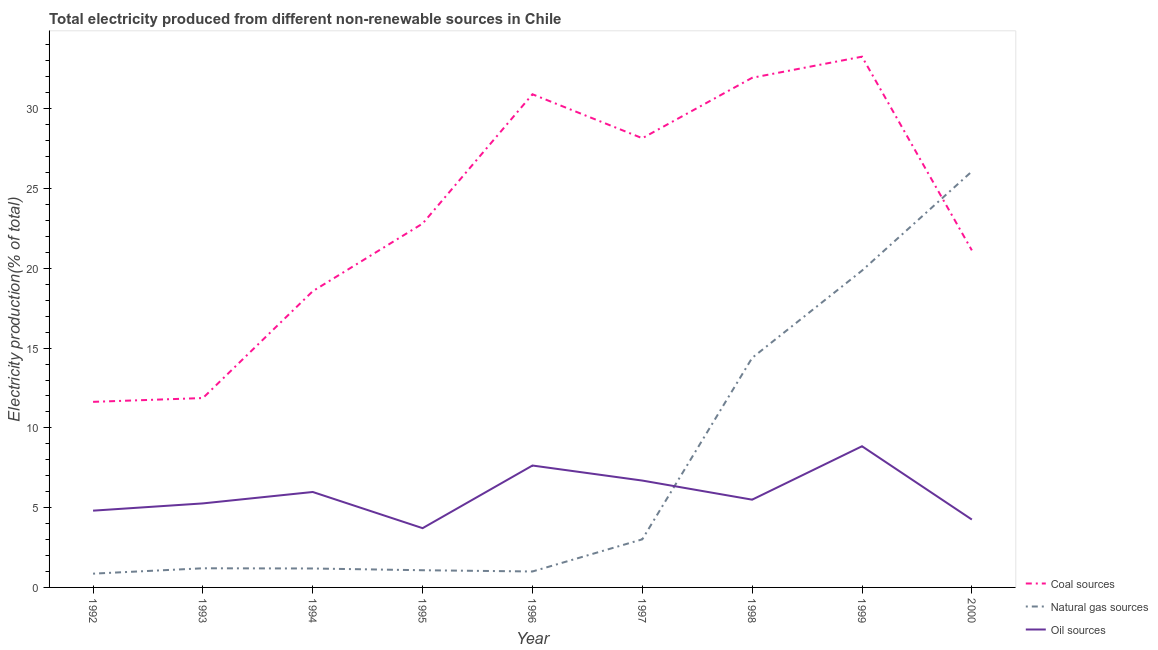Is the number of lines equal to the number of legend labels?
Give a very brief answer. Yes. What is the percentage of electricity produced by natural gas in 1992?
Your answer should be compact. 0.86. Across all years, what is the maximum percentage of electricity produced by coal?
Provide a succinct answer. 33.26. Across all years, what is the minimum percentage of electricity produced by coal?
Ensure brevity in your answer.  11.63. In which year was the percentage of electricity produced by coal minimum?
Ensure brevity in your answer.  1992. What is the total percentage of electricity produced by natural gas in the graph?
Ensure brevity in your answer.  68.66. What is the difference between the percentage of electricity produced by coal in 1993 and that in 1995?
Provide a short and direct response. -10.93. What is the difference between the percentage of electricity produced by oil sources in 1994 and the percentage of electricity produced by coal in 1992?
Your answer should be very brief. -5.65. What is the average percentage of electricity produced by coal per year?
Make the answer very short. 23.36. In the year 1996, what is the difference between the percentage of electricity produced by natural gas and percentage of electricity produced by coal?
Ensure brevity in your answer.  -29.91. What is the ratio of the percentage of electricity produced by coal in 1993 to that in 1995?
Your response must be concise. 0.52. Is the percentage of electricity produced by oil sources in 1994 less than that in 1999?
Offer a very short reply. Yes. What is the difference between the highest and the second highest percentage of electricity produced by coal?
Keep it short and to the point. 1.32. What is the difference between the highest and the lowest percentage of electricity produced by oil sources?
Offer a terse response. 5.13. In how many years, is the percentage of electricity produced by natural gas greater than the average percentage of electricity produced by natural gas taken over all years?
Provide a short and direct response. 3. Is the sum of the percentage of electricity produced by coal in 1992 and 2000 greater than the maximum percentage of electricity produced by oil sources across all years?
Your response must be concise. Yes. How many years are there in the graph?
Make the answer very short. 9. What is the difference between two consecutive major ticks on the Y-axis?
Provide a succinct answer. 5. Are the values on the major ticks of Y-axis written in scientific E-notation?
Ensure brevity in your answer.  No. Does the graph contain any zero values?
Your answer should be compact. No. Does the graph contain grids?
Ensure brevity in your answer.  No. How many legend labels are there?
Your answer should be compact. 3. What is the title of the graph?
Make the answer very short. Total electricity produced from different non-renewable sources in Chile. What is the label or title of the X-axis?
Ensure brevity in your answer.  Year. What is the Electricity production(% of total) in Coal sources in 1992?
Ensure brevity in your answer.  11.63. What is the Electricity production(% of total) in Natural gas sources in 1992?
Provide a succinct answer. 0.86. What is the Electricity production(% of total) in Oil sources in 1992?
Your response must be concise. 4.81. What is the Electricity production(% of total) of Coal sources in 1993?
Give a very brief answer. 11.87. What is the Electricity production(% of total) of Natural gas sources in 1993?
Provide a short and direct response. 1.2. What is the Electricity production(% of total) in Oil sources in 1993?
Provide a short and direct response. 5.27. What is the Electricity production(% of total) in Coal sources in 1994?
Provide a succinct answer. 18.57. What is the Electricity production(% of total) in Natural gas sources in 1994?
Ensure brevity in your answer.  1.19. What is the Electricity production(% of total) of Oil sources in 1994?
Provide a short and direct response. 5.98. What is the Electricity production(% of total) of Coal sources in 1995?
Your answer should be very brief. 22.8. What is the Electricity production(% of total) of Natural gas sources in 1995?
Ensure brevity in your answer.  1.08. What is the Electricity production(% of total) of Oil sources in 1995?
Your answer should be compact. 3.71. What is the Electricity production(% of total) in Coal sources in 1996?
Your answer should be compact. 30.91. What is the Electricity production(% of total) of Natural gas sources in 1996?
Your answer should be compact. 1. What is the Electricity production(% of total) in Oil sources in 1996?
Provide a succinct answer. 7.64. What is the Electricity production(% of total) of Coal sources in 1997?
Keep it short and to the point. 28.15. What is the Electricity production(% of total) of Natural gas sources in 1997?
Ensure brevity in your answer.  3.02. What is the Electricity production(% of total) in Oil sources in 1997?
Keep it short and to the point. 6.7. What is the Electricity production(% of total) in Coal sources in 1998?
Provide a short and direct response. 31.94. What is the Electricity production(% of total) in Natural gas sources in 1998?
Keep it short and to the point. 14.39. What is the Electricity production(% of total) in Oil sources in 1998?
Provide a succinct answer. 5.5. What is the Electricity production(% of total) of Coal sources in 1999?
Offer a very short reply. 33.26. What is the Electricity production(% of total) in Natural gas sources in 1999?
Provide a short and direct response. 19.86. What is the Electricity production(% of total) of Oil sources in 1999?
Provide a succinct answer. 8.85. What is the Electricity production(% of total) of Coal sources in 2000?
Provide a succinct answer. 21.13. What is the Electricity production(% of total) in Natural gas sources in 2000?
Keep it short and to the point. 26.07. What is the Electricity production(% of total) of Oil sources in 2000?
Provide a succinct answer. 4.25. Across all years, what is the maximum Electricity production(% of total) in Coal sources?
Make the answer very short. 33.26. Across all years, what is the maximum Electricity production(% of total) of Natural gas sources?
Provide a succinct answer. 26.07. Across all years, what is the maximum Electricity production(% of total) of Oil sources?
Make the answer very short. 8.85. Across all years, what is the minimum Electricity production(% of total) in Coal sources?
Make the answer very short. 11.63. Across all years, what is the minimum Electricity production(% of total) in Natural gas sources?
Offer a very short reply. 0.86. Across all years, what is the minimum Electricity production(% of total) of Oil sources?
Your answer should be compact. 3.71. What is the total Electricity production(% of total) of Coal sources in the graph?
Make the answer very short. 210.26. What is the total Electricity production(% of total) in Natural gas sources in the graph?
Your answer should be very brief. 68.66. What is the total Electricity production(% of total) in Oil sources in the graph?
Your response must be concise. 52.71. What is the difference between the Electricity production(% of total) of Coal sources in 1992 and that in 1993?
Make the answer very short. -0.24. What is the difference between the Electricity production(% of total) of Natural gas sources in 1992 and that in 1993?
Your answer should be very brief. -0.34. What is the difference between the Electricity production(% of total) in Oil sources in 1992 and that in 1993?
Ensure brevity in your answer.  -0.45. What is the difference between the Electricity production(% of total) of Coal sources in 1992 and that in 1994?
Provide a short and direct response. -6.94. What is the difference between the Electricity production(% of total) in Natural gas sources in 1992 and that in 1994?
Offer a terse response. -0.32. What is the difference between the Electricity production(% of total) of Oil sources in 1992 and that in 1994?
Offer a terse response. -1.17. What is the difference between the Electricity production(% of total) in Coal sources in 1992 and that in 1995?
Give a very brief answer. -11.17. What is the difference between the Electricity production(% of total) of Natural gas sources in 1992 and that in 1995?
Keep it short and to the point. -0.21. What is the difference between the Electricity production(% of total) in Oil sources in 1992 and that in 1995?
Provide a succinct answer. 1.1. What is the difference between the Electricity production(% of total) in Coal sources in 1992 and that in 1996?
Offer a terse response. -19.28. What is the difference between the Electricity production(% of total) of Natural gas sources in 1992 and that in 1996?
Give a very brief answer. -0.14. What is the difference between the Electricity production(% of total) in Oil sources in 1992 and that in 1996?
Provide a succinct answer. -2.83. What is the difference between the Electricity production(% of total) in Coal sources in 1992 and that in 1997?
Offer a very short reply. -16.52. What is the difference between the Electricity production(% of total) in Natural gas sources in 1992 and that in 1997?
Offer a very short reply. -2.15. What is the difference between the Electricity production(% of total) in Oil sources in 1992 and that in 1997?
Provide a short and direct response. -1.89. What is the difference between the Electricity production(% of total) in Coal sources in 1992 and that in 1998?
Keep it short and to the point. -20.31. What is the difference between the Electricity production(% of total) in Natural gas sources in 1992 and that in 1998?
Give a very brief answer. -13.52. What is the difference between the Electricity production(% of total) of Oil sources in 1992 and that in 1998?
Your answer should be very brief. -0.69. What is the difference between the Electricity production(% of total) in Coal sources in 1992 and that in 1999?
Keep it short and to the point. -21.63. What is the difference between the Electricity production(% of total) in Natural gas sources in 1992 and that in 1999?
Ensure brevity in your answer.  -18.99. What is the difference between the Electricity production(% of total) in Oil sources in 1992 and that in 1999?
Your answer should be compact. -4.04. What is the difference between the Electricity production(% of total) in Coal sources in 1992 and that in 2000?
Provide a succinct answer. -9.5. What is the difference between the Electricity production(% of total) in Natural gas sources in 1992 and that in 2000?
Offer a very short reply. -25.21. What is the difference between the Electricity production(% of total) of Oil sources in 1992 and that in 2000?
Make the answer very short. 0.56. What is the difference between the Electricity production(% of total) of Coal sources in 1993 and that in 1994?
Your response must be concise. -6.7. What is the difference between the Electricity production(% of total) of Natural gas sources in 1993 and that in 1994?
Your response must be concise. 0.01. What is the difference between the Electricity production(% of total) of Oil sources in 1993 and that in 1994?
Ensure brevity in your answer.  -0.72. What is the difference between the Electricity production(% of total) of Coal sources in 1993 and that in 1995?
Offer a very short reply. -10.93. What is the difference between the Electricity production(% of total) of Natural gas sources in 1993 and that in 1995?
Keep it short and to the point. 0.12. What is the difference between the Electricity production(% of total) in Oil sources in 1993 and that in 1995?
Provide a succinct answer. 1.55. What is the difference between the Electricity production(% of total) in Coal sources in 1993 and that in 1996?
Your answer should be compact. -19.04. What is the difference between the Electricity production(% of total) in Natural gas sources in 1993 and that in 1996?
Give a very brief answer. 0.2. What is the difference between the Electricity production(% of total) in Oil sources in 1993 and that in 1996?
Provide a succinct answer. -2.37. What is the difference between the Electricity production(% of total) in Coal sources in 1993 and that in 1997?
Your response must be concise. -16.28. What is the difference between the Electricity production(% of total) of Natural gas sources in 1993 and that in 1997?
Give a very brief answer. -1.82. What is the difference between the Electricity production(% of total) in Oil sources in 1993 and that in 1997?
Provide a succinct answer. -1.43. What is the difference between the Electricity production(% of total) in Coal sources in 1993 and that in 1998?
Provide a short and direct response. -20.07. What is the difference between the Electricity production(% of total) in Natural gas sources in 1993 and that in 1998?
Provide a succinct answer. -13.19. What is the difference between the Electricity production(% of total) in Oil sources in 1993 and that in 1998?
Ensure brevity in your answer.  -0.23. What is the difference between the Electricity production(% of total) of Coal sources in 1993 and that in 1999?
Ensure brevity in your answer.  -21.39. What is the difference between the Electricity production(% of total) of Natural gas sources in 1993 and that in 1999?
Keep it short and to the point. -18.66. What is the difference between the Electricity production(% of total) of Oil sources in 1993 and that in 1999?
Your answer should be compact. -3.58. What is the difference between the Electricity production(% of total) of Coal sources in 1993 and that in 2000?
Provide a short and direct response. -9.26. What is the difference between the Electricity production(% of total) in Natural gas sources in 1993 and that in 2000?
Offer a terse response. -24.87. What is the difference between the Electricity production(% of total) in Oil sources in 1993 and that in 2000?
Make the answer very short. 1.01. What is the difference between the Electricity production(% of total) of Coal sources in 1994 and that in 1995?
Your answer should be compact. -4.24. What is the difference between the Electricity production(% of total) in Natural gas sources in 1994 and that in 1995?
Make the answer very short. 0.11. What is the difference between the Electricity production(% of total) of Oil sources in 1994 and that in 1995?
Provide a short and direct response. 2.27. What is the difference between the Electricity production(% of total) of Coal sources in 1994 and that in 1996?
Keep it short and to the point. -12.34. What is the difference between the Electricity production(% of total) of Natural gas sources in 1994 and that in 1996?
Provide a short and direct response. 0.19. What is the difference between the Electricity production(% of total) of Oil sources in 1994 and that in 1996?
Your response must be concise. -1.66. What is the difference between the Electricity production(% of total) of Coal sources in 1994 and that in 1997?
Your response must be concise. -9.59. What is the difference between the Electricity production(% of total) of Natural gas sources in 1994 and that in 1997?
Provide a short and direct response. -1.83. What is the difference between the Electricity production(% of total) in Oil sources in 1994 and that in 1997?
Give a very brief answer. -0.72. What is the difference between the Electricity production(% of total) of Coal sources in 1994 and that in 1998?
Your response must be concise. -13.37. What is the difference between the Electricity production(% of total) in Natural gas sources in 1994 and that in 1998?
Provide a succinct answer. -13.2. What is the difference between the Electricity production(% of total) of Oil sources in 1994 and that in 1998?
Ensure brevity in your answer.  0.48. What is the difference between the Electricity production(% of total) in Coal sources in 1994 and that in 1999?
Keep it short and to the point. -14.7. What is the difference between the Electricity production(% of total) in Natural gas sources in 1994 and that in 1999?
Give a very brief answer. -18.67. What is the difference between the Electricity production(% of total) in Oil sources in 1994 and that in 1999?
Your answer should be compact. -2.87. What is the difference between the Electricity production(% of total) of Coal sources in 1994 and that in 2000?
Your answer should be very brief. -2.56. What is the difference between the Electricity production(% of total) of Natural gas sources in 1994 and that in 2000?
Your answer should be very brief. -24.88. What is the difference between the Electricity production(% of total) in Oil sources in 1994 and that in 2000?
Offer a very short reply. 1.73. What is the difference between the Electricity production(% of total) of Coal sources in 1995 and that in 1996?
Your answer should be very brief. -8.11. What is the difference between the Electricity production(% of total) of Natural gas sources in 1995 and that in 1996?
Ensure brevity in your answer.  0.08. What is the difference between the Electricity production(% of total) in Oil sources in 1995 and that in 1996?
Ensure brevity in your answer.  -3.93. What is the difference between the Electricity production(% of total) of Coal sources in 1995 and that in 1997?
Your response must be concise. -5.35. What is the difference between the Electricity production(% of total) of Natural gas sources in 1995 and that in 1997?
Your answer should be very brief. -1.94. What is the difference between the Electricity production(% of total) in Oil sources in 1995 and that in 1997?
Your answer should be compact. -2.98. What is the difference between the Electricity production(% of total) of Coal sources in 1995 and that in 1998?
Provide a short and direct response. -9.14. What is the difference between the Electricity production(% of total) in Natural gas sources in 1995 and that in 1998?
Offer a terse response. -13.31. What is the difference between the Electricity production(% of total) of Oil sources in 1995 and that in 1998?
Your answer should be very brief. -1.79. What is the difference between the Electricity production(% of total) in Coal sources in 1995 and that in 1999?
Your response must be concise. -10.46. What is the difference between the Electricity production(% of total) in Natural gas sources in 1995 and that in 1999?
Keep it short and to the point. -18.78. What is the difference between the Electricity production(% of total) of Oil sources in 1995 and that in 1999?
Offer a very short reply. -5.13. What is the difference between the Electricity production(% of total) in Coal sources in 1995 and that in 2000?
Provide a succinct answer. 1.68. What is the difference between the Electricity production(% of total) of Natural gas sources in 1995 and that in 2000?
Your response must be concise. -24.99. What is the difference between the Electricity production(% of total) in Oil sources in 1995 and that in 2000?
Make the answer very short. -0.54. What is the difference between the Electricity production(% of total) of Coal sources in 1996 and that in 1997?
Give a very brief answer. 2.76. What is the difference between the Electricity production(% of total) of Natural gas sources in 1996 and that in 1997?
Offer a terse response. -2.02. What is the difference between the Electricity production(% of total) in Oil sources in 1996 and that in 1997?
Give a very brief answer. 0.94. What is the difference between the Electricity production(% of total) in Coal sources in 1996 and that in 1998?
Ensure brevity in your answer.  -1.03. What is the difference between the Electricity production(% of total) in Natural gas sources in 1996 and that in 1998?
Ensure brevity in your answer.  -13.39. What is the difference between the Electricity production(% of total) in Oil sources in 1996 and that in 1998?
Keep it short and to the point. 2.14. What is the difference between the Electricity production(% of total) in Coal sources in 1996 and that in 1999?
Ensure brevity in your answer.  -2.36. What is the difference between the Electricity production(% of total) in Natural gas sources in 1996 and that in 1999?
Make the answer very short. -18.86. What is the difference between the Electricity production(% of total) in Oil sources in 1996 and that in 1999?
Provide a short and direct response. -1.21. What is the difference between the Electricity production(% of total) in Coal sources in 1996 and that in 2000?
Offer a very short reply. 9.78. What is the difference between the Electricity production(% of total) in Natural gas sources in 1996 and that in 2000?
Keep it short and to the point. -25.07. What is the difference between the Electricity production(% of total) of Oil sources in 1996 and that in 2000?
Your answer should be compact. 3.39. What is the difference between the Electricity production(% of total) in Coal sources in 1997 and that in 1998?
Your answer should be very brief. -3.79. What is the difference between the Electricity production(% of total) in Natural gas sources in 1997 and that in 1998?
Offer a very short reply. -11.37. What is the difference between the Electricity production(% of total) of Oil sources in 1997 and that in 1998?
Offer a terse response. 1.2. What is the difference between the Electricity production(% of total) in Coal sources in 1997 and that in 1999?
Provide a succinct answer. -5.11. What is the difference between the Electricity production(% of total) in Natural gas sources in 1997 and that in 1999?
Offer a terse response. -16.84. What is the difference between the Electricity production(% of total) in Oil sources in 1997 and that in 1999?
Your answer should be compact. -2.15. What is the difference between the Electricity production(% of total) of Coal sources in 1997 and that in 2000?
Your answer should be very brief. 7.03. What is the difference between the Electricity production(% of total) in Natural gas sources in 1997 and that in 2000?
Offer a terse response. -23.06. What is the difference between the Electricity production(% of total) in Oil sources in 1997 and that in 2000?
Provide a succinct answer. 2.44. What is the difference between the Electricity production(% of total) in Coal sources in 1998 and that in 1999?
Offer a terse response. -1.32. What is the difference between the Electricity production(% of total) of Natural gas sources in 1998 and that in 1999?
Give a very brief answer. -5.47. What is the difference between the Electricity production(% of total) of Oil sources in 1998 and that in 1999?
Your answer should be very brief. -3.35. What is the difference between the Electricity production(% of total) of Coal sources in 1998 and that in 2000?
Provide a short and direct response. 10.81. What is the difference between the Electricity production(% of total) in Natural gas sources in 1998 and that in 2000?
Offer a terse response. -11.68. What is the difference between the Electricity production(% of total) of Oil sources in 1998 and that in 2000?
Offer a very short reply. 1.25. What is the difference between the Electricity production(% of total) in Coal sources in 1999 and that in 2000?
Offer a very short reply. 12.14. What is the difference between the Electricity production(% of total) in Natural gas sources in 1999 and that in 2000?
Give a very brief answer. -6.21. What is the difference between the Electricity production(% of total) in Oil sources in 1999 and that in 2000?
Give a very brief answer. 4.59. What is the difference between the Electricity production(% of total) of Coal sources in 1992 and the Electricity production(% of total) of Natural gas sources in 1993?
Make the answer very short. 10.43. What is the difference between the Electricity production(% of total) of Coal sources in 1992 and the Electricity production(% of total) of Oil sources in 1993?
Your answer should be very brief. 6.36. What is the difference between the Electricity production(% of total) in Natural gas sources in 1992 and the Electricity production(% of total) in Oil sources in 1993?
Offer a very short reply. -4.4. What is the difference between the Electricity production(% of total) of Coal sources in 1992 and the Electricity production(% of total) of Natural gas sources in 1994?
Make the answer very short. 10.44. What is the difference between the Electricity production(% of total) in Coal sources in 1992 and the Electricity production(% of total) in Oil sources in 1994?
Your response must be concise. 5.65. What is the difference between the Electricity production(% of total) in Natural gas sources in 1992 and the Electricity production(% of total) in Oil sources in 1994?
Make the answer very short. -5.12. What is the difference between the Electricity production(% of total) of Coal sources in 1992 and the Electricity production(% of total) of Natural gas sources in 1995?
Give a very brief answer. 10.55. What is the difference between the Electricity production(% of total) in Coal sources in 1992 and the Electricity production(% of total) in Oil sources in 1995?
Give a very brief answer. 7.92. What is the difference between the Electricity production(% of total) of Natural gas sources in 1992 and the Electricity production(% of total) of Oil sources in 1995?
Your response must be concise. -2.85. What is the difference between the Electricity production(% of total) of Coal sources in 1992 and the Electricity production(% of total) of Natural gas sources in 1996?
Your response must be concise. 10.63. What is the difference between the Electricity production(% of total) in Coal sources in 1992 and the Electricity production(% of total) in Oil sources in 1996?
Your answer should be very brief. 3.99. What is the difference between the Electricity production(% of total) in Natural gas sources in 1992 and the Electricity production(% of total) in Oil sources in 1996?
Offer a terse response. -6.78. What is the difference between the Electricity production(% of total) in Coal sources in 1992 and the Electricity production(% of total) in Natural gas sources in 1997?
Your answer should be compact. 8.62. What is the difference between the Electricity production(% of total) of Coal sources in 1992 and the Electricity production(% of total) of Oil sources in 1997?
Your answer should be very brief. 4.93. What is the difference between the Electricity production(% of total) of Natural gas sources in 1992 and the Electricity production(% of total) of Oil sources in 1997?
Your response must be concise. -5.83. What is the difference between the Electricity production(% of total) in Coal sources in 1992 and the Electricity production(% of total) in Natural gas sources in 1998?
Your response must be concise. -2.76. What is the difference between the Electricity production(% of total) of Coal sources in 1992 and the Electricity production(% of total) of Oil sources in 1998?
Give a very brief answer. 6.13. What is the difference between the Electricity production(% of total) in Natural gas sources in 1992 and the Electricity production(% of total) in Oil sources in 1998?
Provide a short and direct response. -4.64. What is the difference between the Electricity production(% of total) of Coal sources in 1992 and the Electricity production(% of total) of Natural gas sources in 1999?
Your response must be concise. -8.23. What is the difference between the Electricity production(% of total) in Coal sources in 1992 and the Electricity production(% of total) in Oil sources in 1999?
Offer a very short reply. 2.78. What is the difference between the Electricity production(% of total) in Natural gas sources in 1992 and the Electricity production(% of total) in Oil sources in 1999?
Ensure brevity in your answer.  -7.99. What is the difference between the Electricity production(% of total) of Coal sources in 1992 and the Electricity production(% of total) of Natural gas sources in 2000?
Keep it short and to the point. -14.44. What is the difference between the Electricity production(% of total) of Coal sources in 1992 and the Electricity production(% of total) of Oil sources in 2000?
Provide a short and direct response. 7.38. What is the difference between the Electricity production(% of total) of Natural gas sources in 1992 and the Electricity production(% of total) of Oil sources in 2000?
Keep it short and to the point. -3.39. What is the difference between the Electricity production(% of total) of Coal sources in 1993 and the Electricity production(% of total) of Natural gas sources in 1994?
Your answer should be very brief. 10.68. What is the difference between the Electricity production(% of total) of Coal sources in 1993 and the Electricity production(% of total) of Oil sources in 1994?
Make the answer very short. 5.89. What is the difference between the Electricity production(% of total) in Natural gas sources in 1993 and the Electricity production(% of total) in Oil sources in 1994?
Ensure brevity in your answer.  -4.78. What is the difference between the Electricity production(% of total) of Coal sources in 1993 and the Electricity production(% of total) of Natural gas sources in 1995?
Offer a terse response. 10.79. What is the difference between the Electricity production(% of total) of Coal sources in 1993 and the Electricity production(% of total) of Oil sources in 1995?
Provide a succinct answer. 8.16. What is the difference between the Electricity production(% of total) in Natural gas sources in 1993 and the Electricity production(% of total) in Oil sources in 1995?
Offer a very short reply. -2.51. What is the difference between the Electricity production(% of total) in Coal sources in 1993 and the Electricity production(% of total) in Natural gas sources in 1996?
Your answer should be compact. 10.87. What is the difference between the Electricity production(% of total) in Coal sources in 1993 and the Electricity production(% of total) in Oil sources in 1996?
Your response must be concise. 4.23. What is the difference between the Electricity production(% of total) in Natural gas sources in 1993 and the Electricity production(% of total) in Oil sources in 1996?
Your response must be concise. -6.44. What is the difference between the Electricity production(% of total) of Coal sources in 1993 and the Electricity production(% of total) of Natural gas sources in 1997?
Offer a terse response. 8.85. What is the difference between the Electricity production(% of total) of Coal sources in 1993 and the Electricity production(% of total) of Oil sources in 1997?
Give a very brief answer. 5.17. What is the difference between the Electricity production(% of total) of Natural gas sources in 1993 and the Electricity production(% of total) of Oil sources in 1997?
Provide a succinct answer. -5.5. What is the difference between the Electricity production(% of total) of Coal sources in 1993 and the Electricity production(% of total) of Natural gas sources in 1998?
Keep it short and to the point. -2.52. What is the difference between the Electricity production(% of total) in Coal sources in 1993 and the Electricity production(% of total) in Oil sources in 1998?
Offer a terse response. 6.37. What is the difference between the Electricity production(% of total) in Natural gas sources in 1993 and the Electricity production(% of total) in Oil sources in 1998?
Keep it short and to the point. -4.3. What is the difference between the Electricity production(% of total) of Coal sources in 1993 and the Electricity production(% of total) of Natural gas sources in 1999?
Make the answer very short. -7.99. What is the difference between the Electricity production(% of total) of Coal sources in 1993 and the Electricity production(% of total) of Oil sources in 1999?
Offer a terse response. 3.02. What is the difference between the Electricity production(% of total) of Natural gas sources in 1993 and the Electricity production(% of total) of Oil sources in 1999?
Provide a short and direct response. -7.65. What is the difference between the Electricity production(% of total) in Coal sources in 1993 and the Electricity production(% of total) in Natural gas sources in 2000?
Provide a short and direct response. -14.2. What is the difference between the Electricity production(% of total) in Coal sources in 1993 and the Electricity production(% of total) in Oil sources in 2000?
Offer a very short reply. 7.62. What is the difference between the Electricity production(% of total) in Natural gas sources in 1993 and the Electricity production(% of total) in Oil sources in 2000?
Your answer should be compact. -3.05. What is the difference between the Electricity production(% of total) in Coal sources in 1994 and the Electricity production(% of total) in Natural gas sources in 1995?
Provide a succinct answer. 17.49. What is the difference between the Electricity production(% of total) of Coal sources in 1994 and the Electricity production(% of total) of Oil sources in 1995?
Offer a terse response. 14.85. What is the difference between the Electricity production(% of total) of Natural gas sources in 1994 and the Electricity production(% of total) of Oil sources in 1995?
Ensure brevity in your answer.  -2.53. What is the difference between the Electricity production(% of total) of Coal sources in 1994 and the Electricity production(% of total) of Natural gas sources in 1996?
Your answer should be compact. 17.57. What is the difference between the Electricity production(% of total) of Coal sources in 1994 and the Electricity production(% of total) of Oil sources in 1996?
Provide a succinct answer. 10.93. What is the difference between the Electricity production(% of total) of Natural gas sources in 1994 and the Electricity production(% of total) of Oil sources in 1996?
Ensure brevity in your answer.  -6.45. What is the difference between the Electricity production(% of total) in Coal sources in 1994 and the Electricity production(% of total) in Natural gas sources in 1997?
Provide a succinct answer. 15.55. What is the difference between the Electricity production(% of total) in Coal sources in 1994 and the Electricity production(% of total) in Oil sources in 1997?
Give a very brief answer. 11.87. What is the difference between the Electricity production(% of total) of Natural gas sources in 1994 and the Electricity production(% of total) of Oil sources in 1997?
Provide a succinct answer. -5.51. What is the difference between the Electricity production(% of total) in Coal sources in 1994 and the Electricity production(% of total) in Natural gas sources in 1998?
Make the answer very short. 4.18. What is the difference between the Electricity production(% of total) in Coal sources in 1994 and the Electricity production(% of total) in Oil sources in 1998?
Your answer should be very brief. 13.07. What is the difference between the Electricity production(% of total) in Natural gas sources in 1994 and the Electricity production(% of total) in Oil sources in 1998?
Keep it short and to the point. -4.31. What is the difference between the Electricity production(% of total) in Coal sources in 1994 and the Electricity production(% of total) in Natural gas sources in 1999?
Keep it short and to the point. -1.29. What is the difference between the Electricity production(% of total) of Coal sources in 1994 and the Electricity production(% of total) of Oil sources in 1999?
Make the answer very short. 9.72. What is the difference between the Electricity production(% of total) in Natural gas sources in 1994 and the Electricity production(% of total) in Oil sources in 1999?
Your response must be concise. -7.66. What is the difference between the Electricity production(% of total) in Coal sources in 1994 and the Electricity production(% of total) in Natural gas sources in 2000?
Provide a short and direct response. -7.51. What is the difference between the Electricity production(% of total) in Coal sources in 1994 and the Electricity production(% of total) in Oil sources in 2000?
Give a very brief answer. 14.31. What is the difference between the Electricity production(% of total) in Natural gas sources in 1994 and the Electricity production(% of total) in Oil sources in 2000?
Provide a succinct answer. -3.07. What is the difference between the Electricity production(% of total) in Coal sources in 1995 and the Electricity production(% of total) in Natural gas sources in 1996?
Give a very brief answer. 21.8. What is the difference between the Electricity production(% of total) in Coal sources in 1995 and the Electricity production(% of total) in Oil sources in 1996?
Keep it short and to the point. 15.16. What is the difference between the Electricity production(% of total) of Natural gas sources in 1995 and the Electricity production(% of total) of Oil sources in 1996?
Offer a very short reply. -6.56. What is the difference between the Electricity production(% of total) of Coal sources in 1995 and the Electricity production(% of total) of Natural gas sources in 1997?
Give a very brief answer. 19.79. What is the difference between the Electricity production(% of total) of Coal sources in 1995 and the Electricity production(% of total) of Oil sources in 1997?
Provide a short and direct response. 16.11. What is the difference between the Electricity production(% of total) of Natural gas sources in 1995 and the Electricity production(% of total) of Oil sources in 1997?
Offer a terse response. -5.62. What is the difference between the Electricity production(% of total) in Coal sources in 1995 and the Electricity production(% of total) in Natural gas sources in 1998?
Your answer should be very brief. 8.42. What is the difference between the Electricity production(% of total) in Coal sources in 1995 and the Electricity production(% of total) in Oil sources in 1998?
Make the answer very short. 17.3. What is the difference between the Electricity production(% of total) in Natural gas sources in 1995 and the Electricity production(% of total) in Oil sources in 1998?
Make the answer very short. -4.42. What is the difference between the Electricity production(% of total) in Coal sources in 1995 and the Electricity production(% of total) in Natural gas sources in 1999?
Provide a succinct answer. 2.95. What is the difference between the Electricity production(% of total) in Coal sources in 1995 and the Electricity production(% of total) in Oil sources in 1999?
Offer a terse response. 13.95. What is the difference between the Electricity production(% of total) in Natural gas sources in 1995 and the Electricity production(% of total) in Oil sources in 1999?
Provide a succinct answer. -7.77. What is the difference between the Electricity production(% of total) in Coal sources in 1995 and the Electricity production(% of total) in Natural gas sources in 2000?
Your answer should be very brief. -3.27. What is the difference between the Electricity production(% of total) in Coal sources in 1995 and the Electricity production(% of total) in Oil sources in 2000?
Offer a terse response. 18.55. What is the difference between the Electricity production(% of total) in Natural gas sources in 1995 and the Electricity production(% of total) in Oil sources in 2000?
Offer a very short reply. -3.18. What is the difference between the Electricity production(% of total) in Coal sources in 1996 and the Electricity production(% of total) in Natural gas sources in 1997?
Keep it short and to the point. 27.89. What is the difference between the Electricity production(% of total) of Coal sources in 1996 and the Electricity production(% of total) of Oil sources in 1997?
Your answer should be very brief. 24.21. What is the difference between the Electricity production(% of total) of Natural gas sources in 1996 and the Electricity production(% of total) of Oil sources in 1997?
Offer a very short reply. -5.7. What is the difference between the Electricity production(% of total) of Coal sources in 1996 and the Electricity production(% of total) of Natural gas sources in 1998?
Provide a succinct answer. 16.52. What is the difference between the Electricity production(% of total) in Coal sources in 1996 and the Electricity production(% of total) in Oil sources in 1998?
Offer a terse response. 25.41. What is the difference between the Electricity production(% of total) in Natural gas sources in 1996 and the Electricity production(% of total) in Oil sources in 1998?
Ensure brevity in your answer.  -4.5. What is the difference between the Electricity production(% of total) in Coal sources in 1996 and the Electricity production(% of total) in Natural gas sources in 1999?
Offer a very short reply. 11.05. What is the difference between the Electricity production(% of total) of Coal sources in 1996 and the Electricity production(% of total) of Oil sources in 1999?
Your answer should be very brief. 22.06. What is the difference between the Electricity production(% of total) of Natural gas sources in 1996 and the Electricity production(% of total) of Oil sources in 1999?
Provide a short and direct response. -7.85. What is the difference between the Electricity production(% of total) in Coal sources in 1996 and the Electricity production(% of total) in Natural gas sources in 2000?
Provide a succinct answer. 4.84. What is the difference between the Electricity production(% of total) in Coal sources in 1996 and the Electricity production(% of total) in Oil sources in 2000?
Offer a terse response. 26.65. What is the difference between the Electricity production(% of total) in Natural gas sources in 1996 and the Electricity production(% of total) in Oil sources in 2000?
Ensure brevity in your answer.  -3.26. What is the difference between the Electricity production(% of total) in Coal sources in 1997 and the Electricity production(% of total) in Natural gas sources in 1998?
Make the answer very short. 13.76. What is the difference between the Electricity production(% of total) in Coal sources in 1997 and the Electricity production(% of total) in Oil sources in 1998?
Offer a very short reply. 22.65. What is the difference between the Electricity production(% of total) of Natural gas sources in 1997 and the Electricity production(% of total) of Oil sources in 1998?
Keep it short and to the point. -2.48. What is the difference between the Electricity production(% of total) of Coal sources in 1997 and the Electricity production(% of total) of Natural gas sources in 1999?
Offer a terse response. 8.3. What is the difference between the Electricity production(% of total) of Coal sources in 1997 and the Electricity production(% of total) of Oil sources in 1999?
Offer a very short reply. 19.3. What is the difference between the Electricity production(% of total) of Natural gas sources in 1997 and the Electricity production(% of total) of Oil sources in 1999?
Ensure brevity in your answer.  -5.83. What is the difference between the Electricity production(% of total) of Coal sources in 1997 and the Electricity production(% of total) of Natural gas sources in 2000?
Keep it short and to the point. 2.08. What is the difference between the Electricity production(% of total) in Coal sources in 1997 and the Electricity production(% of total) in Oil sources in 2000?
Ensure brevity in your answer.  23.9. What is the difference between the Electricity production(% of total) in Natural gas sources in 1997 and the Electricity production(% of total) in Oil sources in 2000?
Provide a succinct answer. -1.24. What is the difference between the Electricity production(% of total) in Coal sources in 1998 and the Electricity production(% of total) in Natural gas sources in 1999?
Offer a terse response. 12.08. What is the difference between the Electricity production(% of total) of Coal sources in 1998 and the Electricity production(% of total) of Oil sources in 1999?
Keep it short and to the point. 23.09. What is the difference between the Electricity production(% of total) in Natural gas sources in 1998 and the Electricity production(% of total) in Oil sources in 1999?
Give a very brief answer. 5.54. What is the difference between the Electricity production(% of total) in Coal sources in 1998 and the Electricity production(% of total) in Natural gas sources in 2000?
Make the answer very short. 5.87. What is the difference between the Electricity production(% of total) of Coal sources in 1998 and the Electricity production(% of total) of Oil sources in 2000?
Provide a succinct answer. 27.69. What is the difference between the Electricity production(% of total) in Natural gas sources in 1998 and the Electricity production(% of total) in Oil sources in 2000?
Ensure brevity in your answer.  10.13. What is the difference between the Electricity production(% of total) in Coal sources in 1999 and the Electricity production(% of total) in Natural gas sources in 2000?
Keep it short and to the point. 7.19. What is the difference between the Electricity production(% of total) of Coal sources in 1999 and the Electricity production(% of total) of Oil sources in 2000?
Your answer should be compact. 29.01. What is the difference between the Electricity production(% of total) in Natural gas sources in 1999 and the Electricity production(% of total) in Oil sources in 2000?
Provide a short and direct response. 15.6. What is the average Electricity production(% of total) in Coal sources per year?
Your answer should be compact. 23.36. What is the average Electricity production(% of total) of Natural gas sources per year?
Offer a terse response. 7.63. What is the average Electricity production(% of total) in Oil sources per year?
Give a very brief answer. 5.86. In the year 1992, what is the difference between the Electricity production(% of total) in Coal sources and Electricity production(% of total) in Natural gas sources?
Keep it short and to the point. 10.77. In the year 1992, what is the difference between the Electricity production(% of total) of Coal sources and Electricity production(% of total) of Oil sources?
Ensure brevity in your answer.  6.82. In the year 1992, what is the difference between the Electricity production(% of total) in Natural gas sources and Electricity production(% of total) in Oil sources?
Provide a succinct answer. -3.95. In the year 1993, what is the difference between the Electricity production(% of total) of Coal sources and Electricity production(% of total) of Natural gas sources?
Your answer should be very brief. 10.67. In the year 1993, what is the difference between the Electricity production(% of total) of Coal sources and Electricity production(% of total) of Oil sources?
Give a very brief answer. 6.6. In the year 1993, what is the difference between the Electricity production(% of total) in Natural gas sources and Electricity production(% of total) in Oil sources?
Ensure brevity in your answer.  -4.07. In the year 1994, what is the difference between the Electricity production(% of total) of Coal sources and Electricity production(% of total) of Natural gas sources?
Your response must be concise. 17.38. In the year 1994, what is the difference between the Electricity production(% of total) of Coal sources and Electricity production(% of total) of Oil sources?
Offer a terse response. 12.58. In the year 1994, what is the difference between the Electricity production(% of total) of Natural gas sources and Electricity production(% of total) of Oil sources?
Your answer should be compact. -4.79. In the year 1995, what is the difference between the Electricity production(% of total) in Coal sources and Electricity production(% of total) in Natural gas sources?
Make the answer very short. 21.73. In the year 1995, what is the difference between the Electricity production(% of total) in Coal sources and Electricity production(% of total) in Oil sources?
Make the answer very short. 19.09. In the year 1995, what is the difference between the Electricity production(% of total) of Natural gas sources and Electricity production(% of total) of Oil sources?
Your response must be concise. -2.64. In the year 1996, what is the difference between the Electricity production(% of total) in Coal sources and Electricity production(% of total) in Natural gas sources?
Your answer should be compact. 29.91. In the year 1996, what is the difference between the Electricity production(% of total) in Coal sources and Electricity production(% of total) in Oil sources?
Keep it short and to the point. 23.27. In the year 1996, what is the difference between the Electricity production(% of total) of Natural gas sources and Electricity production(% of total) of Oil sources?
Provide a succinct answer. -6.64. In the year 1997, what is the difference between the Electricity production(% of total) in Coal sources and Electricity production(% of total) in Natural gas sources?
Your answer should be very brief. 25.14. In the year 1997, what is the difference between the Electricity production(% of total) of Coal sources and Electricity production(% of total) of Oil sources?
Your answer should be very brief. 21.46. In the year 1997, what is the difference between the Electricity production(% of total) in Natural gas sources and Electricity production(% of total) in Oil sources?
Ensure brevity in your answer.  -3.68. In the year 1998, what is the difference between the Electricity production(% of total) of Coal sources and Electricity production(% of total) of Natural gas sources?
Make the answer very short. 17.55. In the year 1998, what is the difference between the Electricity production(% of total) in Coal sources and Electricity production(% of total) in Oil sources?
Give a very brief answer. 26.44. In the year 1998, what is the difference between the Electricity production(% of total) of Natural gas sources and Electricity production(% of total) of Oil sources?
Your response must be concise. 8.89. In the year 1999, what is the difference between the Electricity production(% of total) of Coal sources and Electricity production(% of total) of Natural gas sources?
Your response must be concise. 13.41. In the year 1999, what is the difference between the Electricity production(% of total) in Coal sources and Electricity production(% of total) in Oil sources?
Keep it short and to the point. 24.42. In the year 1999, what is the difference between the Electricity production(% of total) in Natural gas sources and Electricity production(% of total) in Oil sources?
Make the answer very short. 11.01. In the year 2000, what is the difference between the Electricity production(% of total) in Coal sources and Electricity production(% of total) in Natural gas sources?
Your answer should be very brief. -4.95. In the year 2000, what is the difference between the Electricity production(% of total) of Coal sources and Electricity production(% of total) of Oil sources?
Give a very brief answer. 16.87. In the year 2000, what is the difference between the Electricity production(% of total) in Natural gas sources and Electricity production(% of total) in Oil sources?
Your response must be concise. 21.82. What is the ratio of the Electricity production(% of total) of Coal sources in 1992 to that in 1993?
Your answer should be very brief. 0.98. What is the ratio of the Electricity production(% of total) of Natural gas sources in 1992 to that in 1993?
Make the answer very short. 0.72. What is the ratio of the Electricity production(% of total) in Oil sources in 1992 to that in 1993?
Provide a short and direct response. 0.91. What is the ratio of the Electricity production(% of total) of Coal sources in 1992 to that in 1994?
Your answer should be compact. 0.63. What is the ratio of the Electricity production(% of total) of Natural gas sources in 1992 to that in 1994?
Give a very brief answer. 0.73. What is the ratio of the Electricity production(% of total) of Oil sources in 1992 to that in 1994?
Offer a terse response. 0.8. What is the ratio of the Electricity production(% of total) in Coal sources in 1992 to that in 1995?
Offer a terse response. 0.51. What is the ratio of the Electricity production(% of total) of Natural gas sources in 1992 to that in 1995?
Your answer should be very brief. 0.8. What is the ratio of the Electricity production(% of total) in Oil sources in 1992 to that in 1995?
Your answer should be very brief. 1.3. What is the ratio of the Electricity production(% of total) of Coal sources in 1992 to that in 1996?
Provide a short and direct response. 0.38. What is the ratio of the Electricity production(% of total) in Natural gas sources in 1992 to that in 1996?
Offer a terse response. 0.86. What is the ratio of the Electricity production(% of total) of Oil sources in 1992 to that in 1996?
Offer a terse response. 0.63. What is the ratio of the Electricity production(% of total) in Coal sources in 1992 to that in 1997?
Provide a succinct answer. 0.41. What is the ratio of the Electricity production(% of total) in Natural gas sources in 1992 to that in 1997?
Give a very brief answer. 0.29. What is the ratio of the Electricity production(% of total) in Oil sources in 1992 to that in 1997?
Make the answer very short. 0.72. What is the ratio of the Electricity production(% of total) of Coal sources in 1992 to that in 1998?
Give a very brief answer. 0.36. What is the ratio of the Electricity production(% of total) of Natural gas sources in 1992 to that in 1998?
Give a very brief answer. 0.06. What is the ratio of the Electricity production(% of total) of Oil sources in 1992 to that in 1998?
Provide a short and direct response. 0.87. What is the ratio of the Electricity production(% of total) of Coal sources in 1992 to that in 1999?
Ensure brevity in your answer.  0.35. What is the ratio of the Electricity production(% of total) in Natural gas sources in 1992 to that in 1999?
Provide a succinct answer. 0.04. What is the ratio of the Electricity production(% of total) of Oil sources in 1992 to that in 1999?
Offer a terse response. 0.54. What is the ratio of the Electricity production(% of total) in Coal sources in 1992 to that in 2000?
Make the answer very short. 0.55. What is the ratio of the Electricity production(% of total) of Natural gas sources in 1992 to that in 2000?
Ensure brevity in your answer.  0.03. What is the ratio of the Electricity production(% of total) in Oil sources in 1992 to that in 2000?
Provide a short and direct response. 1.13. What is the ratio of the Electricity production(% of total) in Coal sources in 1993 to that in 1994?
Your answer should be compact. 0.64. What is the ratio of the Electricity production(% of total) of Natural gas sources in 1993 to that in 1994?
Provide a succinct answer. 1.01. What is the ratio of the Electricity production(% of total) in Oil sources in 1993 to that in 1994?
Offer a terse response. 0.88. What is the ratio of the Electricity production(% of total) of Coal sources in 1993 to that in 1995?
Make the answer very short. 0.52. What is the ratio of the Electricity production(% of total) of Natural gas sources in 1993 to that in 1995?
Keep it short and to the point. 1.11. What is the ratio of the Electricity production(% of total) of Oil sources in 1993 to that in 1995?
Give a very brief answer. 1.42. What is the ratio of the Electricity production(% of total) in Coal sources in 1993 to that in 1996?
Make the answer very short. 0.38. What is the ratio of the Electricity production(% of total) in Natural gas sources in 1993 to that in 1996?
Ensure brevity in your answer.  1.2. What is the ratio of the Electricity production(% of total) in Oil sources in 1993 to that in 1996?
Make the answer very short. 0.69. What is the ratio of the Electricity production(% of total) of Coal sources in 1993 to that in 1997?
Give a very brief answer. 0.42. What is the ratio of the Electricity production(% of total) in Natural gas sources in 1993 to that in 1997?
Offer a terse response. 0.4. What is the ratio of the Electricity production(% of total) in Oil sources in 1993 to that in 1997?
Your answer should be compact. 0.79. What is the ratio of the Electricity production(% of total) of Coal sources in 1993 to that in 1998?
Offer a terse response. 0.37. What is the ratio of the Electricity production(% of total) in Natural gas sources in 1993 to that in 1998?
Provide a short and direct response. 0.08. What is the ratio of the Electricity production(% of total) of Oil sources in 1993 to that in 1998?
Offer a terse response. 0.96. What is the ratio of the Electricity production(% of total) in Coal sources in 1993 to that in 1999?
Ensure brevity in your answer.  0.36. What is the ratio of the Electricity production(% of total) of Natural gas sources in 1993 to that in 1999?
Provide a succinct answer. 0.06. What is the ratio of the Electricity production(% of total) of Oil sources in 1993 to that in 1999?
Make the answer very short. 0.6. What is the ratio of the Electricity production(% of total) of Coal sources in 1993 to that in 2000?
Keep it short and to the point. 0.56. What is the ratio of the Electricity production(% of total) in Natural gas sources in 1993 to that in 2000?
Provide a short and direct response. 0.05. What is the ratio of the Electricity production(% of total) of Oil sources in 1993 to that in 2000?
Provide a succinct answer. 1.24. What is the ratio of the Electricity production(% of total) in Coal sources in 1994 to that in 1995?
Your response must be concise. 0.81. What is the ratio of the Electricity production(% of total) of Natural gas sources in 1994 to that in 1995?
Your answer should be compact. 1.1. What is the ratio of the Electricity production(% of total) in Oil sources in 1994 to that in 1995?
Provide a succinct answer. 1.61. What is the ratio of the Electricity production(% of total) of Coal sources in 1994 to that in 1996?
Ensure brevity in your answer.  0.6. What is the ratio of the Electricity production(% of total) of Natural gas sources in 1994 to that in 1996?
Offer a very short reply. 1.19. What is the ratio of the Electricity production(% of total) of Oil sources in 1994 to that in 1996?
Give a very brief answer. 0.78. What is the ratio of the Electricity production(% of total) of Coal sources in 1994 to that in 1997?
Make the answer very short. 0.66. What is the ratio of the Electricity production(% of total) of Natural gas sources in 1994 to that in 1997?
Provide a short and direct response. 0.39. What is the ratio of the Electricity production(% of total) of Oil sources in 1994 to that in 1997?
Give a very brief answer. 0.89. What is the ratio of the Electricity production(% of total) in Coal sources in 1994 to that in 1998?
Offer a terse response. 0.58. What is the ratio of the Electricity production(% of total) of Natural gas sources in 1994 to that in 1998?
Ensure brevity in your answer.  0.08. What is the ratio of the Electricity production(% of total) of Oil sources in 1994 to that in 1998?
Your response must be concise. 1.09. What is the ratio of the Electricity production(% of total) in Coal sources in 1994 to that in 1999?
Your answer should be very brief. 0.56. What is the ratio of the Electricity production(% of total) of Natural gas sources in 1994 to that in 1999?
Your answer should be compact. 0.06. What is the ratio of the Electricity production(% of total) in Oil sources in 1994 to that in 1999?
Your answer should be compact. 0.68. What is the ratio of the Electricity production(% of total) in Coal sources in 1994 to that in 2000?
Your answer should be compact. 0.88. What is the ratio of the Electricity production(% of total) in Natural gas sources in 1994 to that in 2000?
Your response must be concise. 0.05. What is the ratio of the Electricity production(% of total) in Oil sources in 1994 to that in 2000?
Your answer should be very brief. 1.41. What is the ratio of the Electricity production(% of total) of Coal sources in 1995 to that in 1996?
Ensure brevity in your answer.  0.74. What is the ratio of the Electricity production(% of total) in Natural gas sources in 1995 to that in 1996?
Your response must be concise. 1.08. What is the ratio of the Electricity production(% of total) in Oil sources in 1995 to that in 1996?
Your response must be concise. 0.49. What is the ratio of the Electricity production(% of total) in Coal sources in 1995 to that in 1997?
Ensure brevity in your answer.  0.81. What is the ratio of the Electricity production(% of total) in Natural gas sources in 1995 to that in 1997?
Provide a succinct answer. 0.36. What is the ratio of the Electricity production(% of total) of Oil sources in 1995 to that in 1997?
Your answer should be compact. 0.55. What is the ratio of the Electricity production(% of total) of Coal sources in 1995 to that in 1998?
Make the answer very short. 0.71. What is the ratio of the Electricity production(% of total) in Natural gas sources in 1995 to that in 1998?
Offer a very short reply. 0.07. What is the ratio of the Electricity production(% of total) in Oil sources in 1995 to that in 1998?
Your answer should be compact. 0.68. What is the ratio of the Electricity production(% of total) in Coal sources in 1995 to that in 1999?
Provide a succinct answer. 0.69. What is the ratio of the Electricity production(% of total) in Natural gas sources in 1995 to that in 1999?
Offer a terse response. 0.05. What is the ratio of the Electricity production(% of total) in Oil sources in 1995 to that in 1999?
Give a very brief answer. 0.42. What is the ratio of the Electricity production(% of total) of Coal sources in 1995 to that in 2000?
Give a very brief answer. 1.08. What is the ratio of the Electricity production(% of total) of Natural gas sources in 1995 to that in 2000?
Give a very brief answer. 0.04. What is the ratio of the Electricity production(% of total) of Oil sources in 1995 to that in 2000?
Keep it short and to the point. 0.87. What is the ratio of the Electricity production(% of total) in Coal sources in 1996 to that in 1997?
Keep it short and to the point. 1.1. What is the ratio of the Electricity production(% of total) of Natural gas sources in 1996 to that in 1997?
Make the answer very short. 0.33. What is the ratio of the Electricity production(% of total) of Oil sources in 1996 to that in 1997?
Your response must be concise. 1.14. What is the ratio of the Electricity production(% of total) in Coal sources in 1996 to that in 1998?
Make the answer very short. 0.97. What is the ratio of the Electricity production(% of total) of Natural gas sources in 1996 to that in 1998?
Your response must be concise. 0.07. What is the ratio of the Electricity production(% of total) of Oil sources in 1996 to that in 1998?
Give a very brief answer. 1.39. What is the ratio of the Electricity production(% of total) of Coal sources in 1996 to that in 1999?
Offer a terse response. 0.93. What is the ratio of the Electricity production(% of total) in Natural gas sources in 1996 to that in 1999?
Make the answer very short. 0.05. What is the ratio of the Electricity production(% of total) in Oil sources in 1996 to that in 1999?
Make the answer very short. 0.86. What is the ratio of the Electricity production(% of total) in Coal sources in 1996 to that in 2000?
Provide a succinct answer. 1.46. What is the ratio of the Electricity production(% of total) of Natural gas sources in 1996 to that in 2000?
Give a very brief answer. 0.04. What is the ratio of the Electricity production(% of total) in Oil sources in 1996 to that in 2000?
Your answer should be compact. 1.8. What is the ratio of the Electricity production(% of total) in Coal sources in 1997 to that in 1998?
Provide a succinct answer. 0.88. What is the ratio of the Electricity production(% of total) of Natural gas sources in 1997 to that in 1998?
Give a very brief answer. 0.21. What is the ratio of the Electricity production(% of total) of Oil sources in 1997 to that in 1998?
Offer a very short reply. 1.22. What is the ratio of the Electricity production(% of total) of Coal sources in 1997 to that in 1999?
Offer a very short reply. 0.85. What is the ratio of the Electricity production(% of total) of Natural gas sources in 1997 to that in 1999?
Provide a succinct answer. 0.15. What is the ratio of the Electricity production(% of total) of Oil sources in 1997 to that in 1999?
Your response must be concise. 0.76. What is the ratio of the Electricity production(% of total) of Coal sources in 1997 to that in 2000?
Provide a succinct answer. 1.33. What is the ratio of the Electricity production(% of total) of Natural gas sources in 1997 to that in 2000?
Keep it short and to the point. 0.12. What is the ratio of the Electricity production(% of total) of Oil sources in 1997 to that in 2000?
Your answer should be very brief. 1.57. What is the ratio of the Electricity production(% of total) of Coal sources in 1998 to that in 1999?
Give a very brief answer. 0.96. What is the ratio of the Electricity production(% of total) of Natural gas sources in 1998 to that in 1999?
Give a very brief answer. 0.72. What is the ratio of the Electricity production(% of total) of Oil sources in 1998 to that in 1999?
Your answer should be very brief. 0.62. What is the ratio of the Electricity production(% of total) in Coal sources in 1998 to that in 2000?
Provide a short and direct response. 1.51. What is the ratio of the Electricity production(% of total) in Natural gas sources in 1998 to that in 2000?
Ensure brevity in your answer.  0.55. What is the ratio of the Electricity production(% of total) in Oil sources in 1998 to that in 2000?
Make the answer very short. 1.29. What is the ratio of the Electricity production(% of total) of Coal sources in 1999 to that in 2000?
Your response must be concise. 1.57. What is the ratio of the Electricity production(% of total) in Natural gas sources in 1999 to that in 2000?
Your answer should be very brief. 0.76. What is the ratio of the Electricity production(% of total) of Oil sources in 1999 to that in 2000?
Keep it short and to the point. 2.08. What is the difference between the highest and the second highest Electricity production(% of total) in Coal sources?
Your response must be concise. 1.32. What is the difference between the highest and the second highest Electricity production(% of total) of Natural gas sources?
Provide a short and direct response. 6.21. What is the difference between the highest and the second highest Electricity production(% of total) in Oil sources?
Provide a succinct answer. 1.21. What is the difference between the highest and the lowest Electricity production(% of total) in Coal sources?
Offer a very short reply. 21.63. What is the difference between the highest and the lowest Electricity production(% of total) in Natural gas sources?
Provide a succinct answer. 25.21. What is the difference between the highest and the lowest Electricity production(% of total) of Oil sources?
Offer a very short reply. 5.13. 